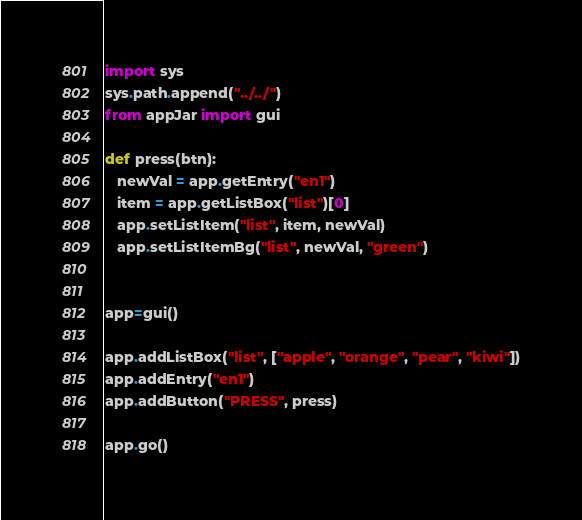<code> <loc_0><loc_0><loc_500><loc_500><_Python_>import sys
sys.path.append("../../")
from appJar import gui

def press(btn):
   newVal = app.getEntry("en1")
   item = app.getListBox("list")[0]
   app.setListItem("list", item, newVal)
   app.setListItemBg("list", newVal, "green")


app=gui()

app.addListBox("list", ["apple", "orange", "pear", "kiwi"])
app.addEntry("en1")
app.addButton("PRESS", press)

app.go()
</code> 